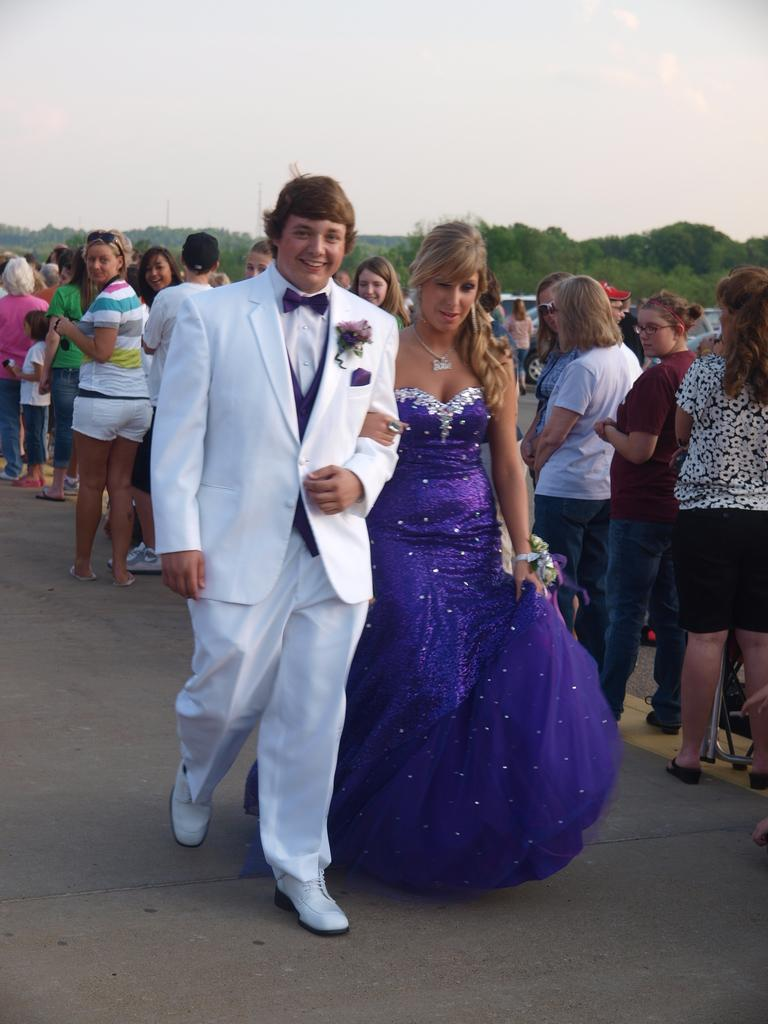What are the main subjects in the image? There is a couple walking in the image. Where are the couple located? The couple is on a road. Are there any other people present in the image? Yes, there are people standing on the road behind the couple. What can be seen in the background of the image? Mountains are visible in the image, and they are covered with trees. Can you spot the spy hiding behind the trees on the mountains in the image? There is no spy present in the image; it only shows a couple walking on a road with people behind them and mountains covered with trees in the background. 